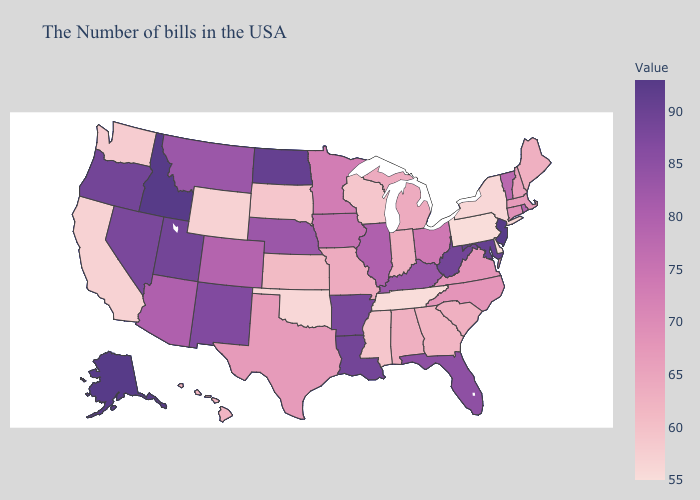Among the states that border Washington , does Oregon have the highest value?
Answer briefly. No. Which states have the lowest value in the USA?
Answer briefly. Delaware, Pennsylvania, Tennessee. 